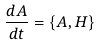<formula> <loc_0><loc_0><loc_500><loc_500>\frac { d A } { d t } = \left \{ A , H \right \}</formula> 